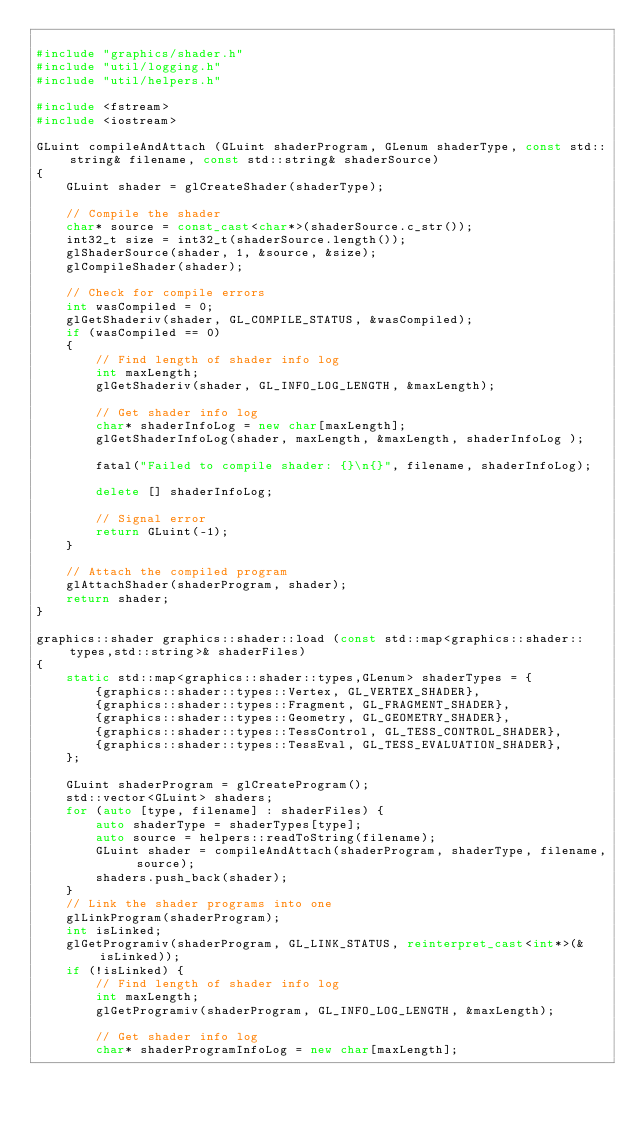Convert code to text. <code><loc_0><loc_0><loc_500><loc_500><_C++_>
#include "graphics/shader.h"
#include "util/logging.h"
#include "util/helpers.h"

#include <fstream>
#include <iostream>

GLuint compileAndAttach (GLuint shaderProgram, GLenum shaderType, const std::string& filename, const std::string& shaderSource)
{
    GLuint shader = glCreateShader(shaderType);

    // Compile the shader
    char* source = const_cast<char*>(shaderSource.c_str());
    int32_t size = int32_t(shaderSource.length());
    glShaderSource(shader, 1, &source, &size);
    glCompileShader(shader);

    // Check for compile errors
    int wasCompiled = 0;
    glGetShaderiv(shader, GL_COMPILE_STATUS, &wasCompiled);
    if (wasCompiled == 0)
    {
        // Find length of shader info log
        int maxLength;
        glGetShaderiv(shader, GL_INFO_LOG_LENGTH, &maxLength);

        // Get shader info log
        char* shaderInfoLog = new char[maxLength];
        glGetShaderInfoLog(shader, maxLength, &maxLength, shaderInfoLog );

        fatal("Failed to compile shader: {}\n{}", filename, shaderInfoLog);

        delete [] shaderInfoLog;

        // Signal error
        return GLuint(-1);
    }

    // Attach the compiled program
    glAttachShader(shaderProgram, shader);
    return shader;
}

graphics::shader graphics::shader::load (const std::map<graphics::shader::types,std::string>& shaderFiles)
{
    static std::map<graphics::shader::types,GLenum> shaderTypes = {
        {graphics::shader::types::Vertex, GL_VERTEX_SHADER},
        {graphics::shader::types::Fragment, GL_FRAGMENT_SHADER},
        {graphics::shader::types::Geometry, GL_GEOMETRY_SHADER},
        {graphics::shader::types::TessControl, GL_TESS_CONTROL_SHADER},
        {graphics::shader::types::TessEval, GL_TESS_EVALUATION_SHADER},
    };

    GLuint shaderProgram = glCreateProgram();
    std::vector<GLuint> shaders;
    for (auto [type, filename] : shaderFiles) {
        auto shaderType = shaderTypes[type];
        auto source = helpers::readToString(filename);
        GLuint shader = compileAndAttach(shaderProgram, shaderType, filename, source);
        shaders.push_back(shader);
    }
    // Link the shader programs into one
    glLinkProgram(shaderProgram);
    int isLinked;
    glGetProgramiv(shaderProgram, GL_LINK_STATUS, reinterpret_cast<int*>(&isLinked));
    if (!isLinked) {
        // Find length of shader info log
        int maxLength;
        glGetProgramiv(shaderProgram, GL_INFO_LOG_LENGTH, &maxLength);

        // Get shader info log
        char* shaderProgramInfoLog = new char[maxLength];</code> 